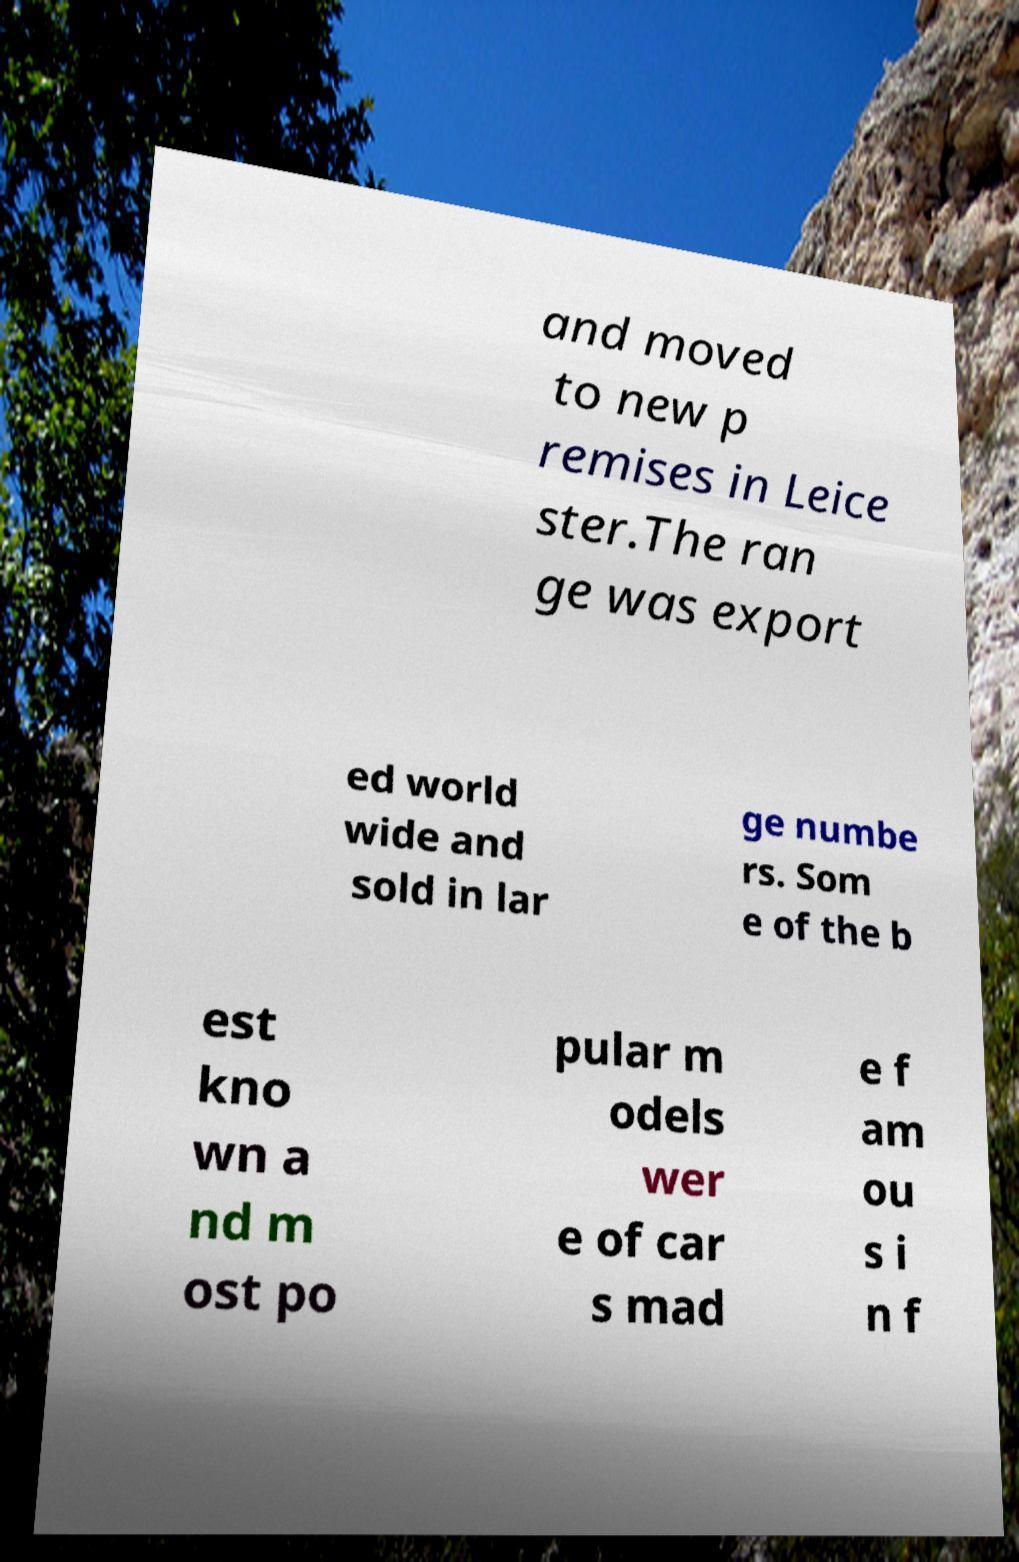Can you read and provide the text displayed in the image?This photo seems to have some interesting text. Can you extract and type it out for me? and moved to new p remises in Leice ster.The ran ge was export ed world wide and sold in lar ge numbe rs. Som e of the b est kno wn a nd m ost po pular m odels wer e of car s mad e f am ou s i n f 